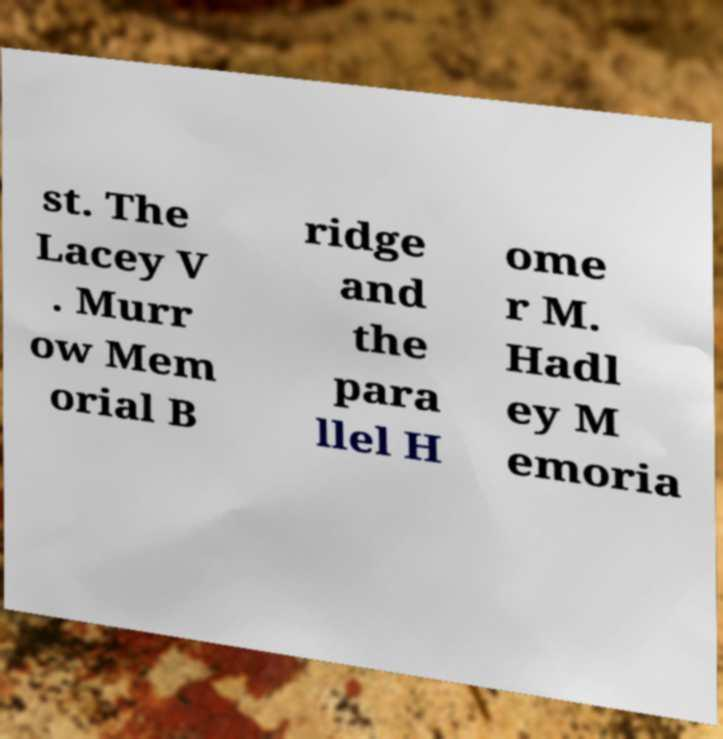Could you assist in decoding the text presented in this image and type it out clearly? st. The Lacey V . Murr ow Mem orial B ridge and the para llel H ome r M. Hadl ey M emoria 